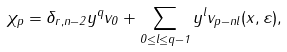Convert formula to latex. <formula><loc_0><loc_0><loc_500><loc_500>\chi _ { p } = \delta _ { r , n - 2 } y ^ { q } v _ { 0 } + \sum _ { 0 \leq l \leq q - 1 } y ^ { l } v _ { p - n l } ( x , \varepsilon ) ,</formula> 